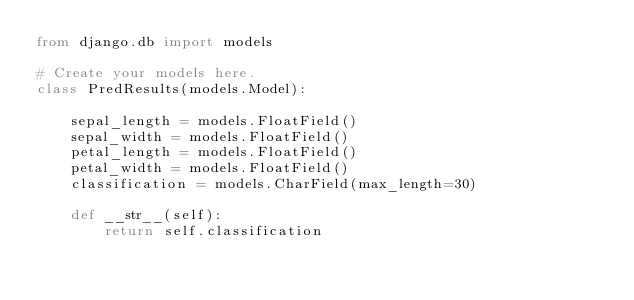<code> <loc_0><loc_0><loc_500><loc_500><_Python_>from django.db import models

# Create your models here.
class PredResults(models.Model):

    sepal_length = models.FloatField()
    sepal_width = models.FloatField()
    petal_length = models.FloatField()
    petal_width = models.FloatField()
    classification = models.CharField(max_length=30)

    def __str__(self):
        return self.classification</code> 